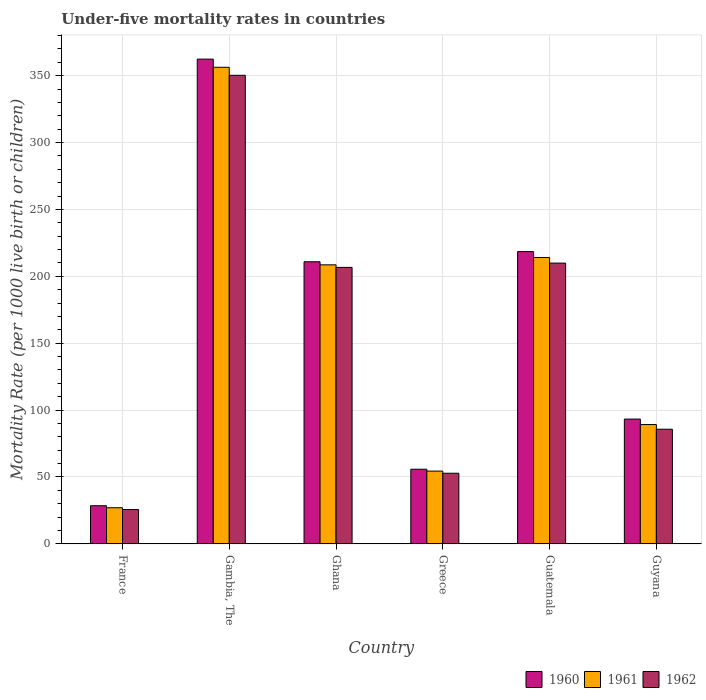How many groups of bars are there?
Keep it short and to the point. 6. Are the number of bars on each tick of the X-axis equal?
Provide a short and direct response. Yes. How many bars are there on the 2nd tick from the left?
Your answer should be compact. 3. In how many cases, is the number of bars for a given country not equal to the number of legend labels?
Your response must be concise. 0. What is the under-five mortality rate in 1960 in Gambia, The?
Your response must be concise. 362.4. Across all countries, what is the maximum under-five mortality rate in 1960?
Offer a very short reply. 362.4. Across all countries, what is the minimum under-five mortality rate in 1962?
Offer a terse response. 25.7. In which country was the under-five mortality rate in 1961 maximum?
Provide a succinct answer. Gambia, The. In which country was the under-five mortality rate in 1961 minimum?
Provide a succinct answer. France. What is the total under-five mortality rate in 1961 in the graph?
Offer a terse response. 949.6. What is the difference between the under-five mortality rate in 1961 in Gambia, The and that in Guatemala?
Offer a terse response. 142.2. What is the difference between the under-five mortality rate in 1961 in Greece and the under-five mortality rate in 1962 in Ghana?
Make the answer very short. -152.3. What is the average under-five mortality rate in 1961 per country?
Your answer should be very brief. 158.27. What is the difference between the under-five mortality rate of/in 1962 and under-five mortality rate of/in 1960 in France?
Offer a terse response. -2.8. In how many countries, is the under-five mortality rate in 1960 greater than 20?
Offer a very short reply. 6. What is the ratio of the under-five mortality rate in 1961 in Greece to that in Guatemala?
Make the answer very short. 0.25. Is the difference between the under-five mortality rate in 1962 in Ghana and Greece greater than the difference between the under-five mortality rate in 1960 in Ghana and Greece?
Provide a short and direct response. No. What is the difference between the highest and the second highest under-five mortality rate in 1961?
Provide a short and direct response. -147.7. What is the difference between the highest and the lowest under-five mortality rate in 1961?
Provide a succinct answer. 329.3. Is the sum of the under-five mortality rate in 1960 in Greece and Guyana greater than the maximum under-five mortality rate in 1961 across all countries?
Offer a terse response. No. Does the graph contain any zero values?
Your answer should be compact. No. Where does the legend appear in the graph?
Make the answer very short. Bottom right. What is the title of the graph?
Give a very brief answer. Under-five mortality rates in countries. What is the label or title of the Y-axis?
Offer a terse response. Mortality Rate (per 1000 live birth or children). What is the Mortality Rate (per 1000 live birth or children) of 1960 in France?
Ensure brevity in your answer.  28.5. What is the Mortality Rate (per 1000 live birth or children) in 1961 in France?
Your response must be concise. 27. What is the Mortality Rate (per 1000 live birth or children) of 1962 in France?
Offer a very short reply. 25.7. What is the Mortality Rate (per 1000 live birth or children) in 1960 in Gambia, The?
Your response must be concise. 362.4. What is the Mortality Rate (per 1000 live birth or children) in 1961 in Gambia, The?
Ensure brevity in your answer.  356.3. What is the Mortality Rate (per 1000 live birth or children) in 1962 in Gambia, The?
Offer a terse response. 350.3. What is the Mortality Rate (per 1000 live birth or children) of 1960 in Ghana?
Your response must be concise. 210.9. What is the Mortality Rate (per 1000 live birth or children) in 1961 in Ghana?
Ensure brevity in your answer.  208.6. What is the Mortality Rate (per 1000 live birth or children) of 1962 in Ghana?
Your answer should be compact. 206.7. What is the Mortality Rate (per 1000 live birth or children) in 1960 in Greece?
Your answer should be very brief. 55.8. What is the Mortality Rate (per 1000 live birth or children) in 1961 in Greece?
Make the answer very short. 54.4. What is the Mortality Rate (per 1000 live birth or children) of 1962 in Greece?
Your answer should be compact. 52.8. What is the Mortality Rate (per 1000 live birth or children) of 1960 in Guatemala?
Your answer should be compact. 218.5. What is the Mortality Rate (per 1000 live birth or children) of 1961 in Guatemala?
Offer a very short reply. 214.1. What is the Mortality Rate (per 1000 live birth or children) in 1962 in Guatemala?
Your response must be concise. 209.9. What is the Mortality Rate (per 1000 live birth or children) in 1960 in Guyana?
Give a very brief answer. 93.3. What is the Mortality Rate (per 1000 live birth or children) in 1961 in Guyana?
Your answer should be compact. 89.2. What is the Mortality Rate (per 1000 live birth or children) in 1962 in Guyana?
Make the answer very short. 85.7. Across all countries, what is the maximum Mortality Rate (per 1000 live birth or children) of 1960?
Your response must be concise. 362.4. Across all countries, what is the maximum Mortality Rate (per 1000 live birth or children) in 1961?
Keep it short and to the point. 356.3. Across all countries, what is the maximum Mortality Rate (per 1000 live birth or children) in 1962?
Give a very brief answer. 350.3. Across all countries, what is the minimum Mortality Rate (per 1000 live birth or children) of 1960?
Your response must be concise. 28.5. Across all countries, what is the minimum Mortality Rate (per 1000 live birth or children) in 1962?
Offer a terse response. 25.7. What is the total Mortality Rate (per 1000 live birth or children) of 1960 in the graph?
Provide a succinct answer. 969.4. What is the total Mortality Rate (per 1000 live birth or children) in 1961 in the graph?
Offer a very short reply. 949.6. What is the total Mortality Rate (per 1000 live birth or children) of 1962 in the graph?
Your answer should be very brief. 931.1. What is the difference between the Mortality Rate (per 1000 live birth or children) in 1960 in France and that in Gambia, The?
Your response must be concise. -333.9. What is the difference between the Mortality Rate (per 1000 live birth or children) of 1961 in France and that in Gambia, The?
Offer a very short reply. -329.3. What is the difference between the Mortality Rate (per 1000 live birth or children) of 1962 in France and that in Gambia, The?
Your response must be concise. -324.6. What is the difference between the Mortality Rate (per 1000 live birth or children) in 1960 in France and that in Ghana?
Offer a very short reply. -182.4. What is the difference between the Mortality Rate (per 1000 live birth or children) in 1961 in France and that in Ghana?
Keep it short and to the point. -181.6. What is the difference between the Mortality Rate (per 1000 live birth or children) in 1962 in France and that in Ghana?
Keep it short and to the point. -181. What is the difference between the Mortality Rate (per 1000 live birth or children) in 1960 in France and that in Greece?
Ensure brevity in your answer.  -27.3. What is the difference between the Mortality Rate (per 1000 live birth or children) in 1961 in France and that in Greece?
Keep it short and to the point. -27.4. What is the difference between the Mortality Rate (per 1000 live birth or children) of 1962 in France and that in Greece?
Offer a very short reply. -27.1. What is the difference between the Mortality Rate (per 1000 live birth or children) of 1960 in France and that in Guatemala?
Your answer should be very brief. -190. What is the difference between the Mortality Rate (per 1000 live birth or children) of 1961 in France and that in Guatemala?
Your response must be concise. -187.1. What is the difference between the Mortality Rate (per 1000 live birth or children) in 1962 in France and that in Guatemala?
Ensure brevity in your answer.  -184.2. What is the difference between the Mortality Rate (per 1000 live birth or children) in 1960 in France and that in Guyana?
Keep it short and to the point. -64.8. What is the difference between the Mortality Rate (per 1000 live birth or children) in 1961 in France and that in Guyana?
Give a very brief answer. -62.2. What is the difference between the Mortality Rate (per 1000 live birth or children) in 1962 in France and that in Guyana?
Your answer should be compact. -60. What is the difference between the Mortality Rate (per 1000 live birth or children) of 1960 in Gambia, The and that in Ghana?
Offer a terse response. 151.5. What is the difference between the Mortality Rate (per 1000 live birth or children) of 1961 in Gambia, The and that in Ghana?
Keep it short and to the point. 147.7. What is the difference between the Mortality Rate (per 1000 live birth or children) of 1962 in Gambia, The and that in Ghana?
Offer a terse response. 143.6. What is the difference between the Mortality Rate (per 1000 live birth or children) in 1960 in Gambia, The and that in Greece?
Keep it short and to the point. 306.6. What is the difference between the Mortality Rate (per 1000 live birth or children) of 1961 in Gambia, The and that in Greece?
Your answer should be very brief. 301.9. What is the difference between the Mortality Rate (per 1000 live birth or children) of 1962 in Gambia, The and that in Greece?
Make the answer very short. 297.5. What is the difference between the Mortality Rate (per 1000 live birth or children) in 1960 in Gambia, The and that in Guatemala?
Your response must be concise. 143.9. What is the difference between the Mortality Rate (per 1000 live birth or children) of 1961 in Gambia, The and that in Guatemala?
Give a very brief answer. 142.2. What is the difference between the Mortality Rate (per 1000 live birth or children) in 1962 in Gambia, The and that in Guatemala?
Provide a succinct answer. 140.4. What is the difference between the Mortality Rate (per 1000 live birth or children) in 1960 in Gambia, The and that in Guyana?
Make the answer very short. 269.1. What is the difference between the Mortality Rate (per 1000 live birth or children) in 1961 in Gambia, The and that in Guyana?
Give a very brief answer. 267.1. What is the difference between the Mortality Rate (per 1000 live birth or children) in 1962 in Gambia, The and that in Guyana?
Provide a short and direct response. 264.6. What is the difference between the Mortality Rate (per 1000 live birth or children) in 1960 in Ghana and that in Greece?
Ensure brevity in your answer.  155.1. What is the difference between the Mortality Rate (per 1000 live birth or children) of 1961 in Ghana and that in Greece?
Your response must be concise. 154.2. What is the difference between the Mortality Rate (per 1000 live birth or children) in 1962 in Ghana and that in Greece?
Ensure brevity in your answer.  153.9. What is the difference between the Mortality Rate (per 1000 live birth or children) in 1960 in Ghana and that in Guatemala?
Give a very brief answer. -7.6. What is the difference between the Mortality Rate (per 1000 live birth or children) of 1960 in Ghana and that in Guyana?
Your answer should be very brief. 117.6. What is the difference between the Mortality Rate (per 1000 live birth or children) of 1961 in Ghana and that in Guyana?
Offer a very short reply. 119.4. What is the difference between the Mortality Rate (per 1000 live birth or children) of 1962 in Ghana and that in Guyana?
Provide a succinct answer. 121. What is the difference between the Mortality Rate (per 1000 live birth or children) in 1960 in Greece and that in Guatemala?
Offer a terse response. -162.7. What is the difference between the Mortality Rate (per 1000 live birth or children) of 1961 in Greece and that in Guatemala?
Your response must be concise. -159.7. What is the difference between the Mortality Rate (per 1000 live birth or children) in 1962 in Greece and that in Guatemala?
Give a very brief answer. -157.1. What is the difference between the Mortality Rate (per 1000 live birth or children) in 1960 in Greece and that in Guyana?
Your answer should be very brief. -37.5. What is the difference between the Mortality Rate (per 1000 live birth or children) in 1961 in Greece and that in Guyana?
Keep it short and to the point. -34.8. What is the difference between the Mortality Rate (per 1000 live birth or children) in 1962 in Greece and that in Guyana?
Keep it short and to the point. -32.9. What is the difference between the Mortality Rate (per 1000 live birth or children) of 1960 in Guatemala and that in Guyana?
Your response must be concise. 125.2. What is the difference between the Mortality Rate (per 1000 live birth or children) of 1961 in Guatemala and that in Guyana?
Keep it short and to the point. 124.9. What is the difference between the Mortality Rate (per 1000 live birth or children) in 1962 in Guatemala and that in Guyana?
Your answer should be very brief. 124.2. What is the difference between the Mortality Rate (per 1000 live birth or children) in 1960 in France and the Mortality Rate (per 1000 live birth or children) in 1961 in Gambia, The?
Keep it short and to the point. -327.8. What is the difference between the Mortality Rate (per 1000 live birth or children) of 1960 in France and the Mortality Rate (per 1000 live birth or children) of 1962 in Gambia, The?
Your response must be concise. -321.8. What is the difference between the Mortality Rate (per 1000 live birth or children) of 1961 in France and the Mortality Rate (per 1000 live birth or children) of 1962 in Gambia, The?
Give a very brief answer. -323.3. What is the difference between the Mortality Rate (per 1000 live birth or children) of 1960 in France and the Mortality Rate (per 1000 live birth or children) of 1961 in Ghana?
Give a very brief answer. -180.1. What is the difference between the Mortality Rate (per 1000 live birth or children) in 1960 in France and the Mortality Rate (per 1000 live birth or children) in 1962 in Ghana?
Provide a short and direct response. -178.2. What is the difference between the Mortality Rate (per 1000 live birth or children) in 1961 in France and the Mortality Rate (per 1000 live birth or children) in 1962 in Ghana?
Your response must be concise. -179.7. What is the difference between the Mortality Rate (per 1000 live birth or children) of 1960 in France and the Mortality Rate (per 1000 live birth or children) of 1961 in Greece?
Ensure brevity in your answer.  -25.9. What is the difference between the Mortality Rate (per 1000 live birth or children) of 1960 in France and the Mortality Rate (per 1000 live birth or children) of 1962 in Greece?
Your answer should be compact. -24.3. What is the difference between the Mortality Rate (per 1000 live birth or children) in 1961 in France and the Mortality Rate (per 1000 live birth or children) in 1962 in Greece?
Your answer should be compact. -25.8. What is the difference between the Mortality Rate (per 1000 live birth or children) in 1960 in France and the Mortality Rate (per 1000 live birth or children) in 1961 in Guatemala?
Keep it short and to the point. -185.6. What is the difference between the Mortality Rate (per 1000 live birth or children) in 1960 in France and the Mortality Rate (per 1000 live birth or children) in 1962 in Guatemala?
Provide a short and direct response. -181.4. What is the difference between the Mortality Rate (per 1000 live birth or children) in 1961 in France and the Mortality Rate (per 1000 live birth or children) in 1962 in Guatemala?
Ensure brevity in your answer.  -182.9. What is the difference between the Mortality Rate (per 1000 live birth or children) of 1960 in France and the Mortality Rate (per 1000 live birth or children) of 1961 in Guyana?
Give a very brief answer. -60.7. What is the difference between the Mortality Rate (per 1000 live birth or children) of 1960 in France and the Mortality Rate (per 1000 live birth or children) of 1962 in Guyana?
Keep it short and to the point. -57.2. What is the difference between the Mortality Rate (per 1000 live birth or children) of 1961 in France and the Mortality Rate (per 1000 live birth or children) of 1962 in Guyana?
Provide a succinct answer. -58.7. What is the difference between the Mortality Rate (per 1000 live birth or children) of 1960 in Gambia, The and the Mortality Rate (per 1000 live birth or children) of 1961 in Ghana?
Your response must be concise. 153.8. What is the difference between the Mortality Rate (per 1000 live birth or children) of 1960 in Gambia, The and the Mortality Rate (per 1000 live birth or children) of 1962 in Ghana?
Your answer should be compact. 155.7. What is the difference between the Mortality Rate (per 1000 live birth or children) of 1961 in Gambia, The and the Mortality Rate (per 1000 live birth or children) of 1962 in Ghana?
Ensure brevity in your answer.  149.6. What is the difference between the Mortality Rate (per 1000 live birth or children) of 1960 in Gambia, The and the Mortality Rate (per 1000 live birth or children) of 1961 in Greece?
Your response must be concise. 308. What is the difference between the Mortality Rate (per 1000 live birth or children) of 1960 in Gambia, The and the Mortality Rate (per 1000 live birth or children) of 1962 in Greece?
Ensure brevity in your answer.  309.6. What is the difference between the Mortality Rate (per 1000 live birth or children) in 1961 in Gambia, The and the Mortality Rate (per 1000 live birth or children) in 1962 in Greece?
Your answer should be very brief. 303.5. What is the difference between the Mortality Rate (per 1000 live birth or children) in 1960 in Gambia, The and the Mortality Rate (per 1000 live birth or children) in 1961 in Guatemala?
Offer a very short reply. 148.3. What is the difference between the Mortality Rate (per 1000 live birth or children) in 1960 in Gambia, The and the Mortality Rate (per 1000 live birth or children) in 1962 in Guatemala?
Offer a terse response. 152.5. What is the difference between the Mortality Rate (per 1000 live birth or children) in 1961 in Gambia, The and the Mortality Rate (per 1000 live birth or children) in 1962 in Guatemala?
Provide a short and direct response. 146.4. What is the difference between the Mortality Rate (per 1000 live birth or children) of 1960 in Gambia, The and the Mortality Rate (per 1000 live birth or children) of 1961 in Guyana?
Your answer should be compact. 273.2. What is the difference between the Mortality Rate (per 1000 live birth or children) in 1960 in Gambia, The and the Mortality Rate (per 1000 live birth or children) in 1962 in Guyana?
Offer a terse response. 276.7. What is the difference between the Mortality Rate (per 1000 live birth or children) of 1961 in Gambia, The and the Mortality Rate (per 1000 live birth or children) of 1962 in Guyana?
Make the answer very short. 270.6. What is the difference between the Mortality Rate (per 1000 live birth or children) in 1960 in Ghana and the Mortality Rate (per 1000 live birth or children) in 1961 in Greece?
Keep it short and to the point. 156.5. What is the difference between the Mortality Rate (per 1000 live birth or children) of 1960 in Ghana and the Mortality Rate (per 1000 live birth or children) of 1962 in Greece?
Your answer should be very brief. 158.1. What is the difference between the Mortality Rate (per 1000 live birth or children) in 1961 in Ghana and the Mortality Rate (per 1000 live birth or children) in 1962 in Greece?
Your answer should be compact. 155.8. What is the difference between the Mortality Rate (per 1000 live birth or children) in 1960 in Ghana and the Mortality Rate (per 1000 live birth or children) in 1962 in Guatemala?
Offer a terse response. 1. What is the difference between the Mortality Rate (per 1000 live birth or children) of 1961 in Ghana and the Mortality Rate (per 1000 live birth or children) of 1962 in Guatemala?
Offer a terse response. -1.3. What is the difference between the Mortality Rate (per 1000 live birth or children) in 1960 in Ghana and the Mortality Rate (per 1000 live birth or children) in 1961 in Guyana?
Your answer should be very brief. 121.7. What is the difference between the Mortality Rate (per 1000 live birth or children) in 1960 in Ghana and the Mortality Rate (per 1000 live birth or children) in 1962 in Guyana?
Your response must be concise. 125.2. What is the difference between the Mortality Rate (per 1000 live birth or children) in 1961 in Ghana and the Mortality Rate (per 1000 live birth or children) in 1962 in Guyana?
Your answer should be very brief. 122.9. What is the difference between the Mortality Rate (per 1000 live birth or children) in 1960 in Greece and the Mortality Rate (per 1000 live birth or children) in 1961 in Guatemala?
Provide a succinct answer. -158.3. What is the difference between the Mortality Rate (per 1000 live birth or children) in 1960 in Greece and the Mortality Rate (per 1000 live birth or children) in 1962 in Guatemala?
Keep it short and to the point. -154.1. What is the difference between the Mortality Rate (per 1000 live birth or children) in 1961 in Greece and the Mortality Rate (per 1000 live birth or children) in 1962 in Guatemala?
Offer a very short reply. -155.5. What is the difference between the Mortality Rate (per 1000 live birth or children) of 1960 in Greece and the Mortality Rate (per 1000 live birth or children) of 1961 in Guyana?
Provide a succinct answer. -33.4. What is the difference between the Mortality Rate (per 1000 live birth or children) of 1960 in Greece and the Mortality Rate (per 1000 live birth or children) of 1962 in Guyana?
Provide a short and direct response. -29.9. What is the difference between the Mortality Rate (per 1000 live birth or children) of 1961 in Greece and the Mortality Rate (per 1000 live birth or children) of 1962 in Guyana?
Ensure brevity in your answer.  -31.3. What is the difference between the Mortality Rate (per 1000 live birth or children) of 1960 in Guatemala and the Mortality Rate (per 1000 live birth or children) of 1961 in Guyana?
Provide a succinct answer. 129.3. What is the difference between the Mortality Rate (per 1000 live birth or children) in 1960 in Guatemala and the Mortality Rate (per 1000 live birth or children) in 1962 in Guyana?
Keep it short and to the point. 132.8. What is the difference between the Mortality Rate (per 1000 live birth or children) in 1961 in Guatemala and the Mortality Rate (per 1000 live birth or children) in 1962 in Guyana?
Provide a short and direct response. 128.4. What is the average Mortality Rate (per 1000 live birth or children) of 1960 per country?
Provide a succinct answer. 161.57. What is the average Mortality Rate (per 1000 live birth or children) in 1961 per country?
Offer a terse response. 158.27. What is the average Mortality Rate (per 1000 live birth or children) of 1962 per country?
Give a very brief answer. 155.18. What is the difference between the Mortality Rate (per 1000 live birth or children) in 1960 and Mortality Rate (per 1000 live birth or children) in 1961 in France?
Keep it short and to the point. 1.5. What is the difference between the Mortality Rate (per 1000 live birth or children) in 1961 and Mortality Rate (per 1000 live birth or children) in 1962 in France?
Your answer should be very brief. 1.3. What is the difference between the Mortality Rate (per 1000 live birth or children) in 1960 and Mortality Rate (per 1000 live birth or children) in 1962 in Gambia, The?
Give a very brief answer. 12.1. What is the difference between the Mortality Rate (per 1000 live birth or children) in 1960 and Mortality Rate (per 1000 live birth or children) in 1962 in Ghana?
Your answer should be very brief. 4.2. What is the difference between the Mortality Rate (per 1000 live birth or children) of 1961 and Mortality Rate (per 1000 live birth or children) of 1962 in Ghana?
Make the answer very short. 1.9. What is the difference between the Mortality Rate (per 1000 live birth or children) in 1960 and Mortality Rate (per 1000 live birth or children) in 1962 in Greece?
Provide a short and direct response. 3. What is the difference between the Mortality Rate (per 1000 live birth or children) of 1961 and Mortality Rate (per 1000 live birth or children) of 1962 in Greece?
Your answer should be very brief. 1.6. What is the difference between the Mortality Rate (per 1000 live birth or children) in 1960 and Mortality Rate (per 1000 live birth or children) in 1961 in Guatemala?
Offer a terse response. 4.4. What is the difference between the Mortality Rate (per 1000 live birth or children) of 1960 and Mortality Rate (per 1000 live birth or children) of 1961 in Guyana?
Offer a very short reply. 4.1. What is the difference between the Mortality Rate (per 1000 live birth or children) in 1960 and Mortality Rate (per 1000 live birth or children) in 1962 in Guyana?
Your answer should be compact. 7.6. What is the difference between the Mortality Rate (per 1000 live birth or children) in 1961 and Mortality Rate (per 1000 live birth or children) in 1962 in Guyana?
Provide a succinct answer. 3.5. What is the ratio of the Mortality Rate (per 1000 live birth or children) of 1960 in France to that in Gambia, The?
Your answer should be compact. 0.08. What is the ratio of the Mortality Rate (per 1000 live birth or children) in 1961 in France to that in Gambia, The?
Give a very brief answer. 0.08. What is the ratio of the Mortality Rate (per 1000 live birth or children) of 1962 in France to that in Gambia, The?
Offer a very short reply. 0.07. What is the ratio of the Mortality Rate (per 1000 live birth or children) in 1960 in France to that in Ghana?
Offer a very short reply. 0.14. What is the ratio of the Mortality Rate (per 1000 live birth or children) in 1961 in France to that in Ghana?
Offer a terse response. 0.13. What is the ratio of the Mortality Rate (per 1000 live birth or children) of 1962 in France to that in Ghana?
Provide a succinct answer. 0.12. What is the ratio of the Mortality Rate (per 1000 live birth or children) in 1960 in France to that in Greece?
Make the answer very short. 0.51. What is the ratio of the Mortality Rate (per 1000 live birth or children) in 1961 in France to that in Greece?
Your answer should be very brief. 0.5. What is the ratio of the Mortality Rate (per 1000 live birth or children) in 1962 in France to that in Greece?
Provide a succinct answer. 0.49. What is the ratio of the Mortality Rate (per 1000 live birth or children) of 1960 in France to that in Guatemala?
Your answer should be compact. 0.13. What is the ratio of the Mortality Rate (per 1000 live birth or children) of 1961 in France to that in Guatemala?
Provide a short and direct response. 0.13. What is the ratio of the Mortality Rate (per 1000 live birth or children) of 1962 in France to that in Guatemala?
Offer a very short reply. 0.12. What is the ratio of the Mortality Rate (per 1000 live birth or children) in 1960 in France to that in Guyana?
Offer a very short reply. 0.31. What is the ratio of the Mortality Rate (per 1000 live birth or children) of 1961 in France to that in Guyana?
Ensure brevity in your answer.  0.3. What is the ratio of the Mortality Rate (per 1000 live birth or children) in 1962 in France to that in Guyana?
Your answer should be compact. 0.3. What is the ratio of the Mortality Rate (per 1000 live birth or children) in 1960 in Gambia, The to that in Ghana?
Ensure brevity in your answer.  1.72. What is the ratio of the Mortality Rate (per 1000 live birth or children) of 1961 in Gambia, The to that in Ghana?
Give a very brief answer. 1.71. What is the ratio of the Mortality Rate (per 1000 live birth or children) in 1962 in Gambia, The to that in Ghana?
Keep it short and to the point. 1.69. What is the ratio of the Mortality Rate (per 1000 live birth or children) of 1960 in Gambia, The to that in Greece?
Your response must be concise. 6.49. What is the ratio of the Mortality Rate (per 1000 live birth or children) of 1961 in Gambia, The to that in Greece?
Give a very brief answer. 6.55. What is the ratio of the Mortality Rate (per 1000 live birth or children) in 1962 in Gambia, The to that in Greece?
Provide a succinct answer. 6.63. What is the ratio of the Mortality Rate (per 1000 live birth or children) in 1960 in Gambia, The to that in Guatemala?
Your response must be concise. 1.66. What is the ratio of the Mortality Rate (per 1000 live birth or children) of 1961 in Gambia, The to that in Guatemala?
Keep it short and to the point. 1.66. What is the ratio of the Mortality Rate (per 1000 live birth or children) of 1962 in Gambia, The to that in Guatemala?
Make the answer very short. 1.67. What is the ratio of the Mortality Rate (per 1000 live birth or children) in 1960 in Gambia, The to that in Guyana?
Your response must be concise. 3.88. What is the ratio of the Mortality Rate (per 1000 live birth or children) of 1961 in Gambia, The to that in Guyana?
Ensure brevity in your answer.  3.99. What is the ratio of the Mortality Rate (per 1000 live birth or children) of 1962 in Gambia, The to that in Guyana?
Ensure brevity in your answer.  4.09. What is the ratio of the Mortality Rate (per 1000 live birth or children) in 1960 in Ghana to that in Greece?
Your answer should be very brief. 3.78. What is the ratio of the Mortality Rate (per 1000 live birth or children) of 1961 in Ghana to that in Greece?
Your response must be concise. 3.83. What is the ratio of the Mortality Rate (per 1000 live birth or children) of 1962 in Ghana to that in Greece?
Make the answer very short. 3.91. What is the ratio of the Mortality Rate (per 1000 live birth or children) in 1960 in Ghana to that in Guatemala?
Your answer should be compact. 0.97. What is the ratio of the Mortality Rate (per 1000 live birth or children) of 1961 in Ghana to that in Guatemala?
Give a very brief answer. 0.97. What is the ratio of the Mortality Rate (per 1000 live birth or children) in 1962 in Ghana to that in Guatemala?
Keep it short and to the point. 0.98. What is the ratio of the Mortality Rate (per 1000 live birth or children) of 1960 in Ghana to that in Guyana?
Give a very brief answer. 2.26. What is the ratio of the Mortality Rate (per 1000 live birth or children) in 1961 in Ghana to that in Guyana?
Your response must be concise. 2.34. What is the ratio of the Mortality Rate (per 1000 live birth or children) of 1962 in Ghana to that in Guyana?
Keep it short and to the point. 2.41. What is the ratio of the Mortality Rate (per 1000 live birth or children) in 1960 in Greece to that in Guatemala?
Your answer should be compact. 0.26. What is the ratio of the Mortality Rate (per 1000 live birth or children) in 1961 in Greece to that in Guatemala?
Offer a terse response. 0.25. What is the ratio of the Mortality Rate (per 1000 live birth or children) of 1962 in Greece to that in Guatemala?
Give a very brief answer. 0.25. What is the ratio of the Mortality Rate (per 1000 live birth or children) of 1960 in Greece to that in Guyana?
Keep it short and to the point. 0.6. What is the ratio of the Mortality Rate (per 1000 live birth or children) of 1961 in Greece to that in Guyana?
Provide a succinct answer. 0.61. What is the ratio of the Mortality Rate (per 1000 live birth or children) of 1962 in Greece to that in Guyana?
Keep it short and to the point. 0.62. What is the ratio of the Mortality Rate (per 1000 live birth or children) of 1960 in Guatemala to that in Guyana?
Your answer should be compact. 2.34. What is the ratio of the Mortality Rate (per 1000 live birth or children) in 1961 in Guatemala to that in Guyana?
Your answer should be compact. 2.4. What is the ratio of the Mortality Rate (per 1000 live birth or children) of 1962 in Guatemala to that in Guyana?
Make the answer very short. 2.45. What is the difference between the highest and the second highest Mortality Rate (per 1000 live birth or children) in 1960?
Your response must be concise. 143.9. What is the difference between the highest and the second highest Mortality Rate (per 1000 live birth or children) of 1961?
Offer a terse response. 142.2. What is the difference between the highest and the second highest Mortality Rate (per 1000 live birth or children) of 1962?
Your response must be concise. 140.4. What is the difference between the highest and the lowest Mortality Rate (per 1000 live birth or children) in 1960?
Provide a succinct answer. 333.9. What is the difference between the highest and the lowest Mortality Rate (per 1000 live birth or children) in 1961?
Provide a short and direct response. 329.3. What is the difference between the highest and the lowest Mortality Rate (per 1000 live birth or children) of 1962?
Your response must be concise. 324.6. 